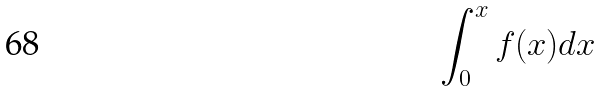Convert formula to latex. <formula><loc_0><loc_0><loc_500><loc_500>\int _ { 0 } ^ { x } f ( x ) d x</formula> 